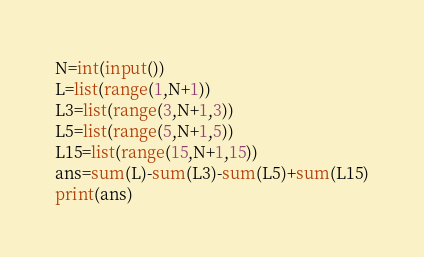Convert code to text. <code><loc_0><loc_0><loc_500><loc_500><_Python_>N=int(input())
L=list(range(1,N+1))
L3=list(range(3,N+1,3))
L5=list(range(5,N+1,5))
L15=list(range(15,N+1,15))
ans=sum(L)-sum(L3)-sum(L5)+sum(L15)
print(ans)</code> 